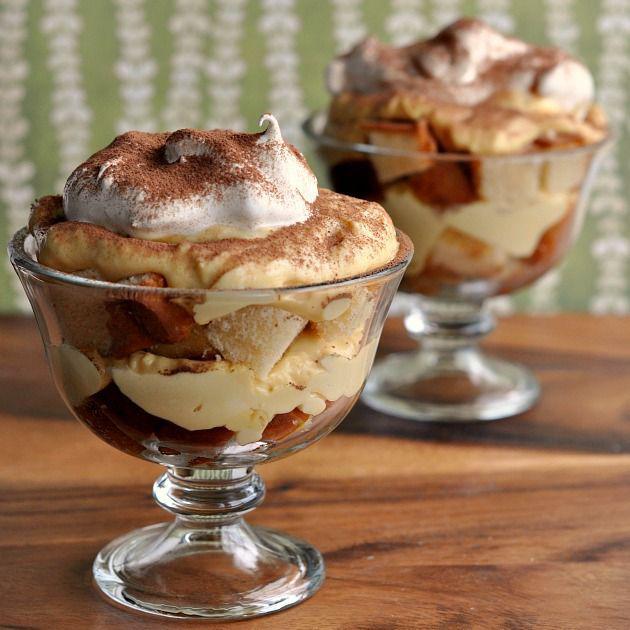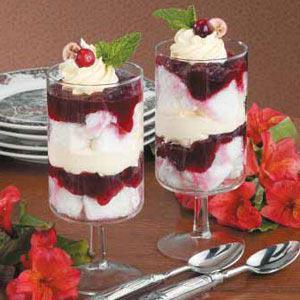The first image is the image on the left, the second image is the image on the right. For the images displayed, is the sentence "There are two servings of desserts in the image on the right." factually correct? Answer yes or no. Yes. 